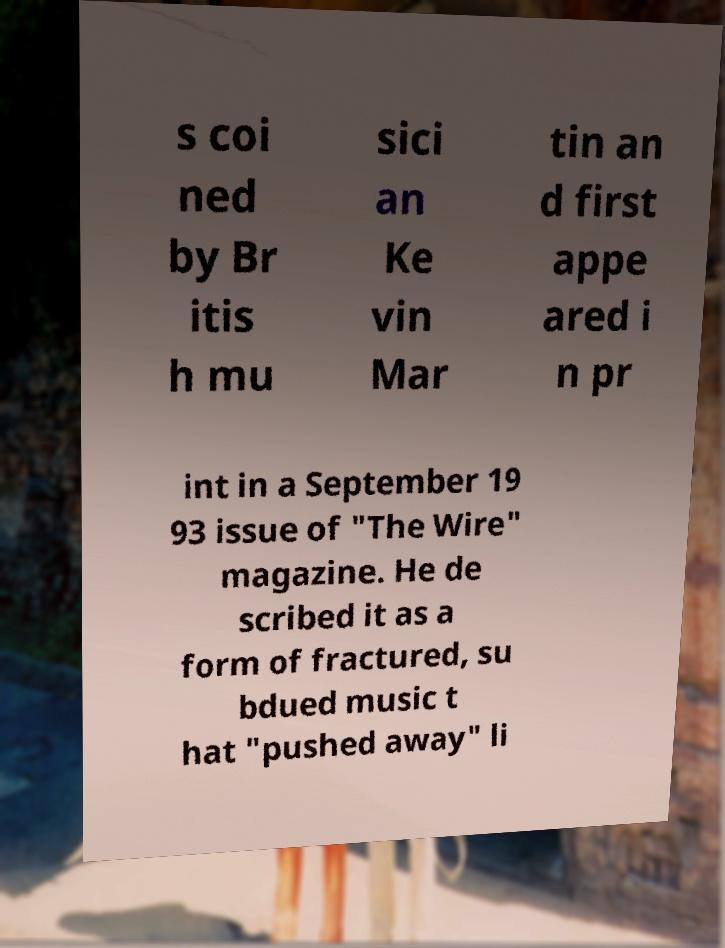Can you read and provide the text displayed in the image?This photo seems to have some interesting text. Can you extract and type it out for me? s coi ned by Br itis h mu sici an Ke vin Mar tin an d first appe ared i n pr int in a September 19 93 issue of "The Wire" magazine. He de scribed it as a form of fractured, su bdued music t hat "pushed away" li 